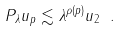<formula> <loc_0><loc_0><loc_500><loc_500>\| P _ { \lambda } u \| _ { p } \lesssim \lambda ^ { \rho ( p ) } \| u \| _ { 2 } \ .</formula> 